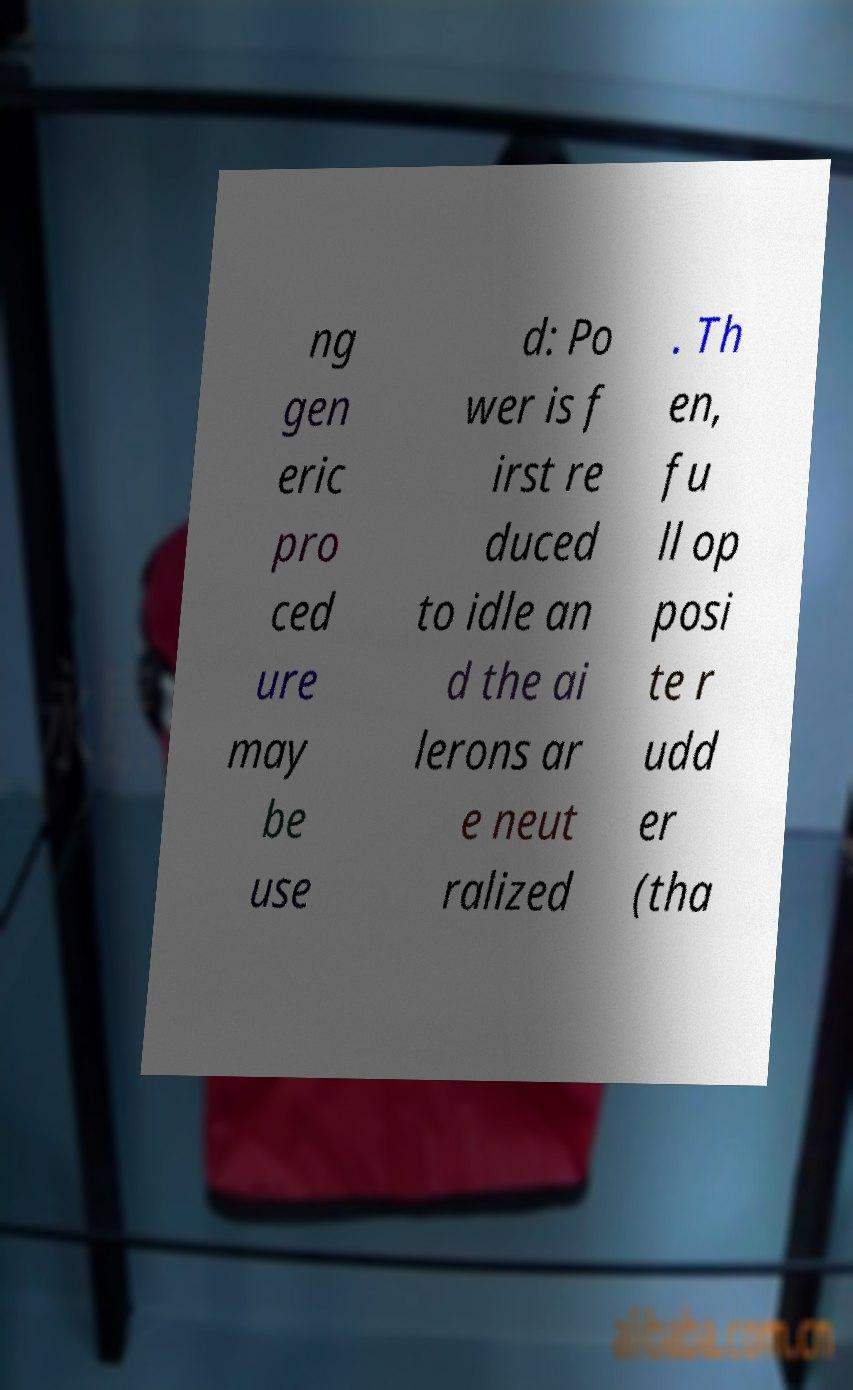Please read and relay the text visible in this image. What does it say? ng gen eric pro ced ure may be use d: Po wer is f irst re duced to idle an d the ai lerons ar e neut ralized . Th en, fu ll op posi te r udd er (tha 